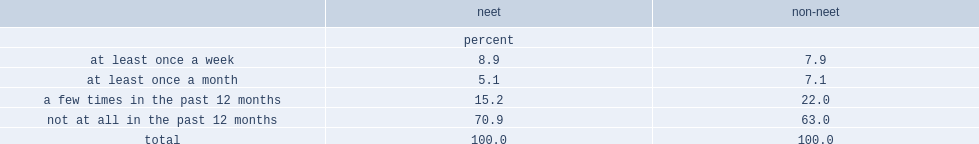What percent of neet individuals had volunteered for a group or organization to some extent over the period. 29.2. What percent of the non-neet population had volunteered for a group or organization to some extent over the period. 37. Among those who had volunteered, what is the most common answer? A few times in the past 12 months. 